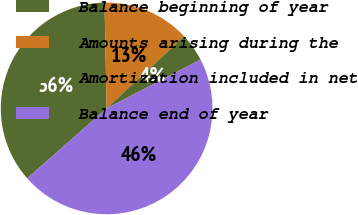Convert chart. <chart><loc_0><loc_0><loc_500><loc_500><pie_chart><fcel>Balance beginning of year<fcel>Amounts arising during the<fcel>Amortization included in net<fcel>Balance end of year<nl><fcel>36.18%<fcel>13.39%<fcel>4.3%<fcel>46.14%<nl></chart> 